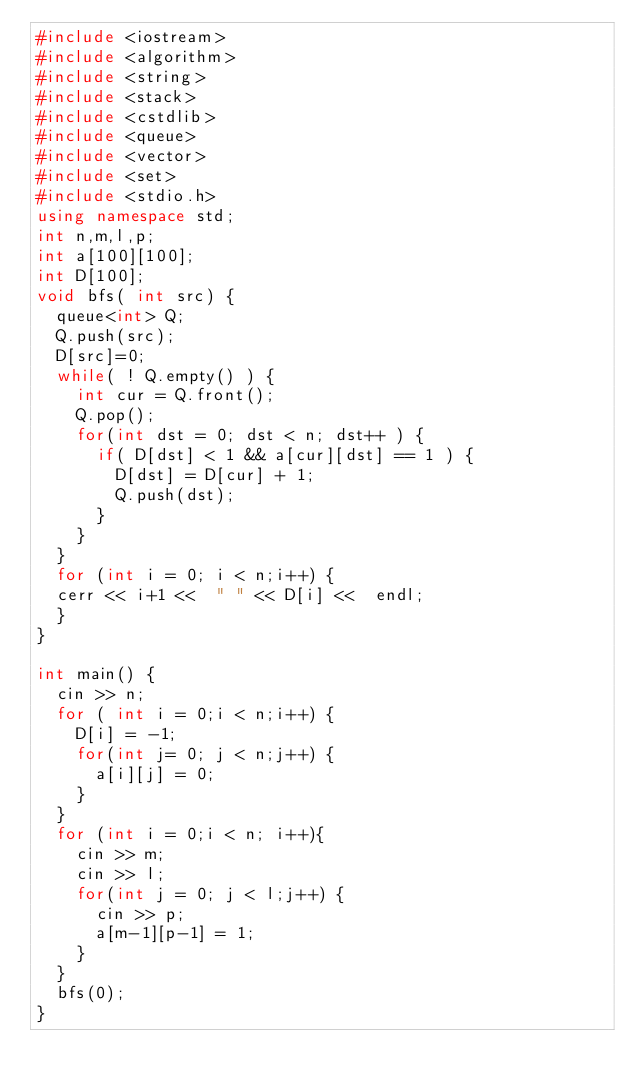Convert code to text. <code><loc_0><loc_0><loc_500><loc_500><_C++_>#include <iostream>
#include <algorithm>
#include <string>
#include <stack>
#include <cstdlib>
#include <queue>
#include <vector>
#include <set>
#include <stdio.h>
using namespace std;
int n,m,l,p;
int a[100][100];
int D[100];
void bfs( int src) {
	queue<int> Q;
	Q.push(src);
	D[src]=0;
	while( ! Q.empty() ) {
		int cur = Q.front();
		Q.pop();
		for(int dst = 0; dst < n; dst++ ) {
			if( D[dst] < 1 && a[cur][dst] == 1 ) {
				D[dst] = D[cur] + 1;
				Q.push(dst);
			}
		}
	}
	for (int i = 0; i < n;i++) {
	cerr << i+1 <<  " " << D[i] <<  endl;
	}
}

int main() {
	cin >> n;
	for ( int i = 0;i < n;i++) {
		D[i] = -1;
		for(int j= 0; j < n;j++) {
			a[i][j] = 0;
		}
	}
	for (int i = 0;i < n; i++){
		cin >> m;
		cin >> l;
		for(int j = 0; j < l;j++) {
			cin >> p;
			a[m-1][p-1] = 1;
		}
	}
	bfs(0);
}
		</code> 